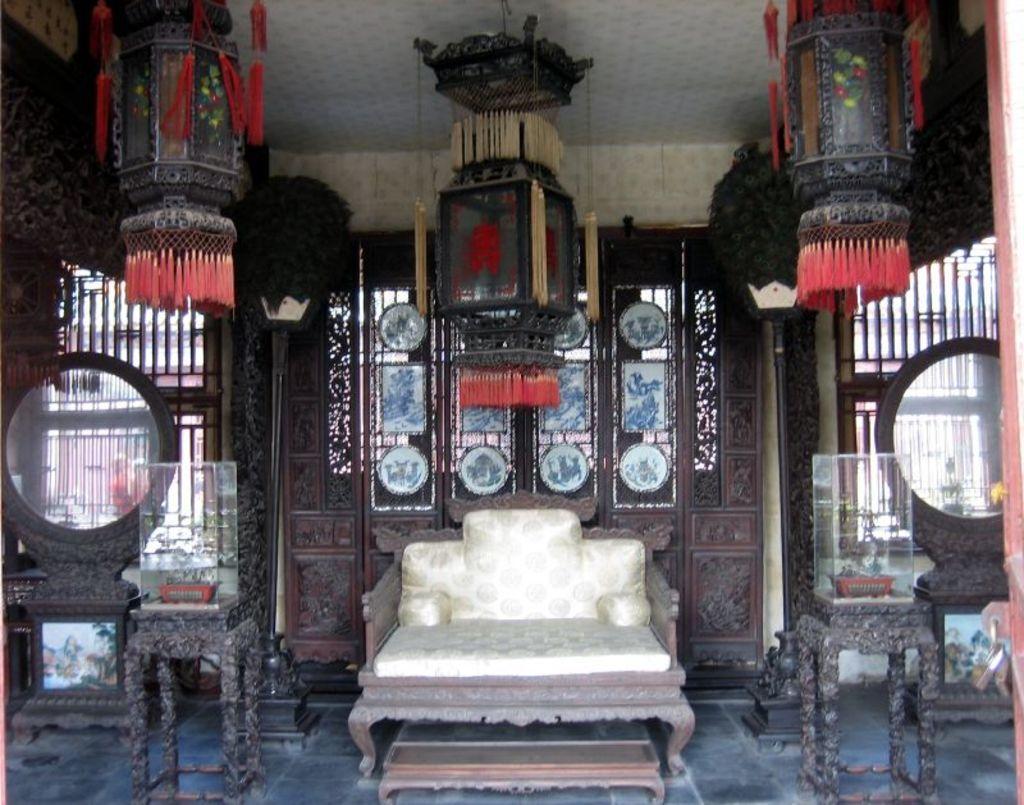Please provide a concise description of this image. In this image I can see a couch, tables, mirror tables, glass boxes along with plants, light poles, lantern lamps, designed wooden wall, frames, windows, roof and objects.   